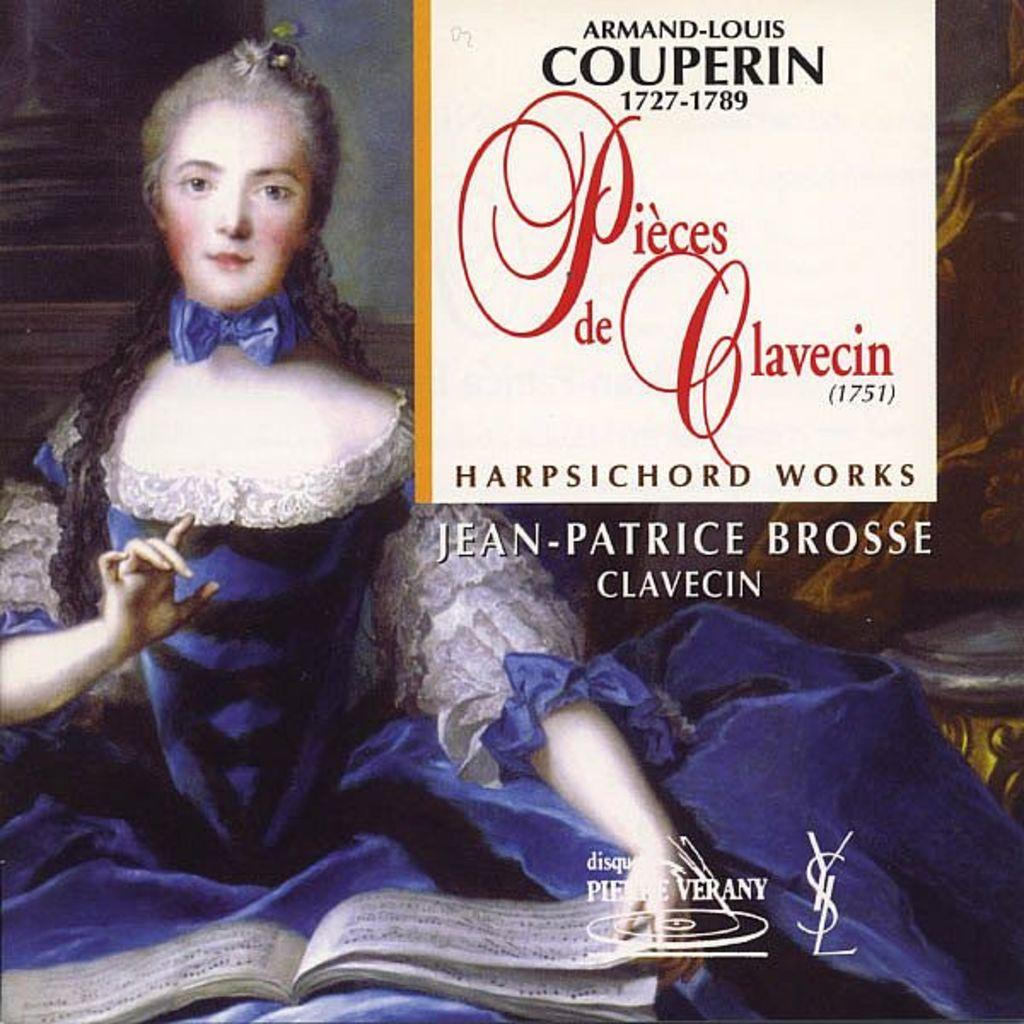Provide a one-sentence caption for the provided image. cd of harpsichord works called pieces de clavecin. 